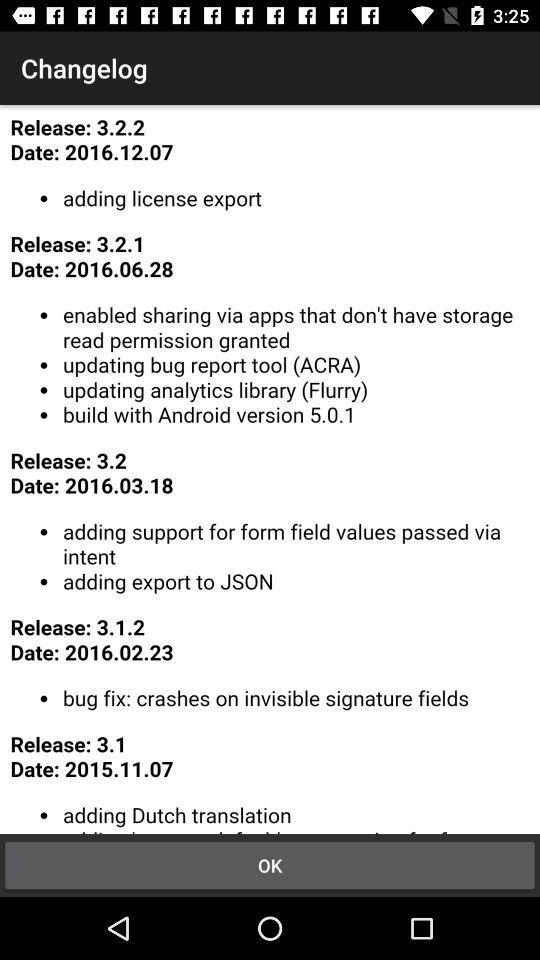What is the latest release log? The latest release log is 3.2.2. 